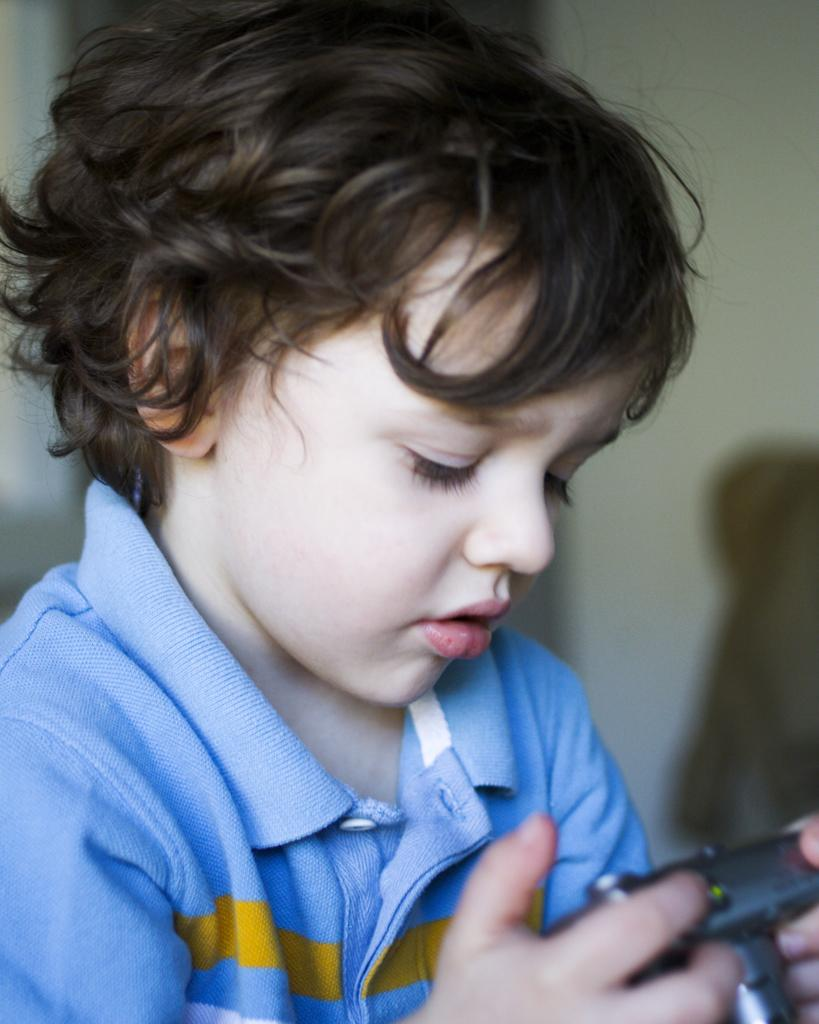What is the main subject of the image? There is a kid in the center of the image. What is the kid holding in the image? The kid is holding an object. What can be seen in the background of the image? There is a wall in the background of the image. Where is the library located in the image? There is no library present in the image. How many cattle can be seen in the image? There are no cattle present in the image. 